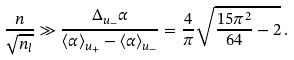<formula> <loc_0><loc_0><loc_500><loc_500>\frac { n } { \sqrt { n _ { l } } } \gg \frac { \Delta _ { u _ { - } } \alpha } { \langle \alpha \rangle _ { u _ { + } } - \langle \alpha \rangle _ { u _ { - } } } = \frac { 4 } { \pi } \sqrt { \frac { 1 5 \pi ^ { 2 } } { 6 4 } - 2 } \, .</formula> 